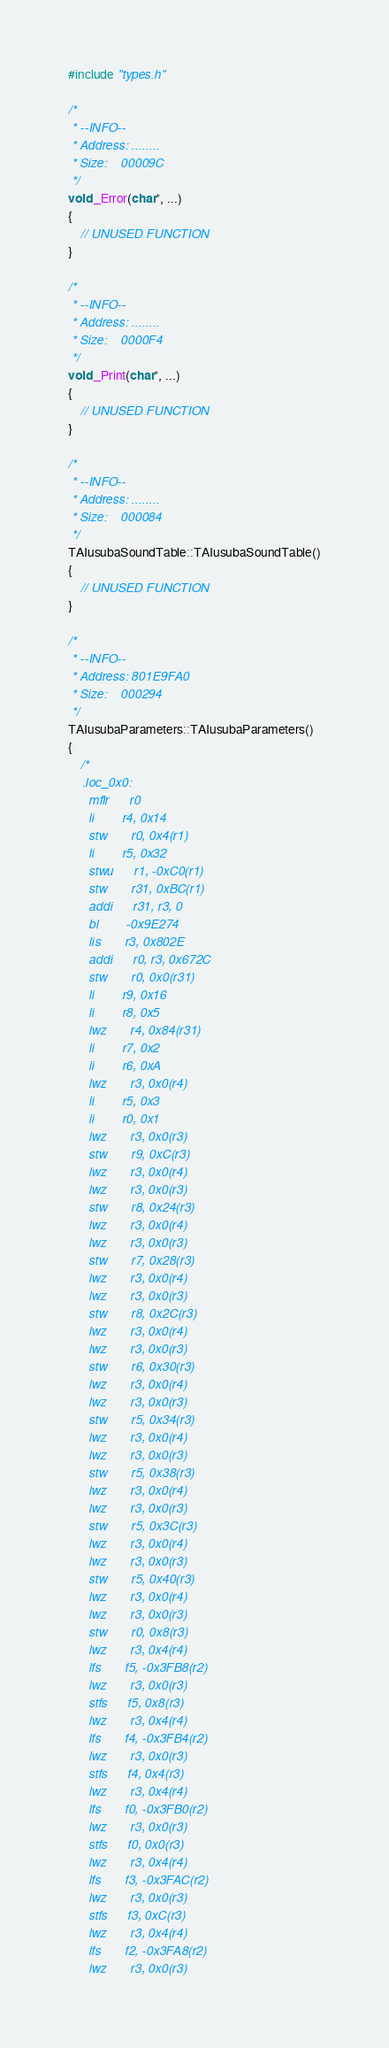Convert code to text. <code><loc_0><loc_0><loc_500><loc_500><_C++_>#include "types.h"

/*
 * --INFO--
 * Address:	........
 * Size:	00009C
 */
void _Error(char*, ...)
{
	// UNUSED FUNCTION
}

/*
 * --INFO--
 * Address:	........
 * Size:	0000F4
 */
void _Print(char*, ...)
{
	// UNUSED FUNCTION
}

/*
 * --INFO--
 * Address:	........
 * Size:	000084
 */
TAIusubaSoundTable::TAIusubaSoundTable()
{
	// UNUSED FUNCTION
}

/*
 * --INFO--
 * Address:	801E9FA0
 * Size:	000294
 */
TAIusubaParameters::TAIusubaParameters()
{
	/*
	.loc_0x0:
	  mflr      r0
	  li        r4, 0x14
	  stw       r0, 0x4(r1)
	  li        r5, 0x32
	  stwu      r1, -0xC0(r1)
	  stw       r31, 0xBC(r1)
	  addi      r31, r3, 0
	  bl        -0x9E274
	  lis       r3, 0x802E
	  addi      r0, r3, 0x672C
	  stw       r0, 0x0(r31)
	  li        r9, 0x16
	  li        r8, 0x5
	  lwz       r4, 0x84(r31)
	  li        r7, 0x2
	  li        r6, 0xA
	  lwz       r3, 0x0(r4)
	  li        r5, 0x3
	  li        r0, 0x1
	  lwz       r3, 0x0(r3)
	  stw       r9, 0xC(r3)
	  lwz       r3, 0x0(r4)
	  lwz       r3, 0x0(r3)
	  stw       r8, 0x24(r3)
	  lwz       r3, 0x0(r4)
	  lwz       r3, 0x0(r3)
	  stw       r7, 0x28(r3)
	  lwz       r3, 0x0(r4)
	  lwz       r3, 0x0(r3)
	  stw       r8, 0x2C(r3)
	  lwz       r3, 0x0(r4)
	  lwz       r3, 0x0(r3)
	  stw       r6, 0x30(r3)
	  lwz       r3, 0x0(r4)
	  lwz       r3, 0x0(r3)
	  stw       r5, 0x34(r3)
	  lwz       r3, 0x0(r4)
	  lwz       r3, 0x0(r3)
	  stw       r5, 0x38(r3)
	  lwz       r3, 0x0(r4)
	  lwz       r3, 0x0(r3)
	  stw       r5, 0x3C(r3)
	  lwz       r3, 0x0(r4)
	  lwz       r3, 0x0(r3)
	  stw       r5, 0x40(r3)
	  lwz       r3, 0x0(r4)
	  lwz       r3, 0x0(r3)
	  stw       r0, 0x8(r3)
	  lwz       r3, 0x4(r4)
	  lfs       f5, -0x3FB8(r2)
	  lwz       r3, 0x0(r3)
	  stfs      f5, 0x8(r3)
	  lwz       r3, 0x4(r4)
	  lfs       f4, -0x3FB4(r2)
	  lwz       r3, 0x0(r3)
	  stfs      f4, 0x4(r3)
	  lwz       r3, 0x4(r4)
	  lfs       f0, -0x3FB0(r2)
	  lwz       r3, 0x0(r3)
	  stfs      f0, 0x0(r3)
	  lwz       r3, 0x4(r4)
	  lfs       f3, -0x3FAC(r2)
	  lwz       r3, 0x0(r3)
	  stfs      f3, 0xC(r3)
	  lwz       r3, 0x4(r4)
	  lfs       f2, -0x3FA8(r2)
	  lwz       r3, 0x0(r3)</code> 